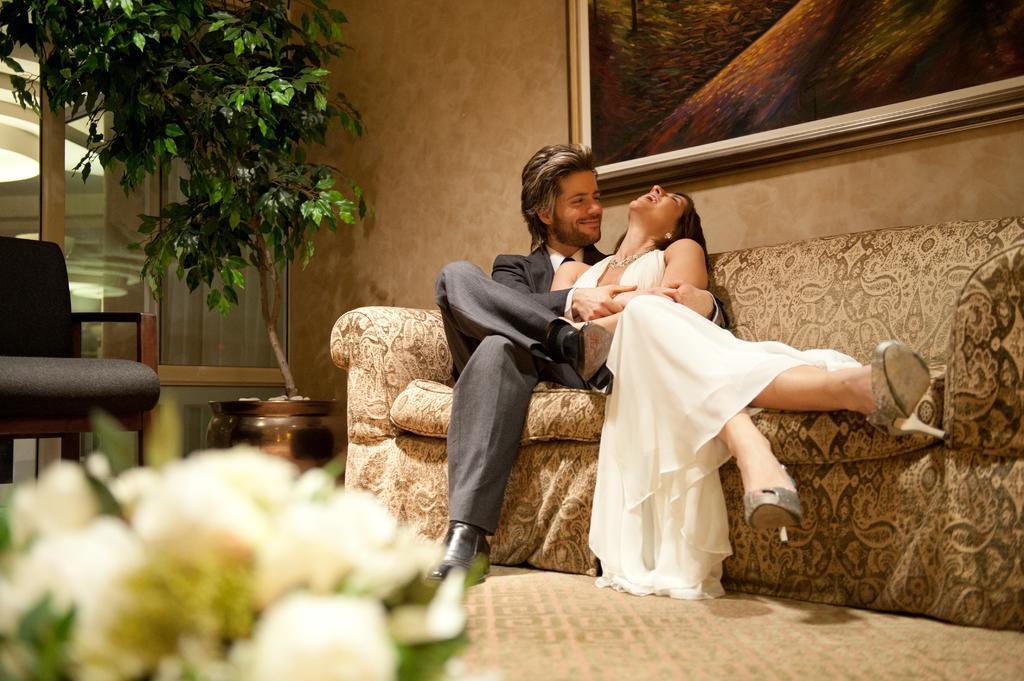Could you give a brief overview of what you see in this image? In this image there are two people sitting on the couch, there is a wall, there is a photo frame truncated towards the left of the image, there is a plant in the flower pot, there is a chair truncated towards the left of the image, there is a light truncated, there is a roof, there are flowers truncated towards the left of the image. 